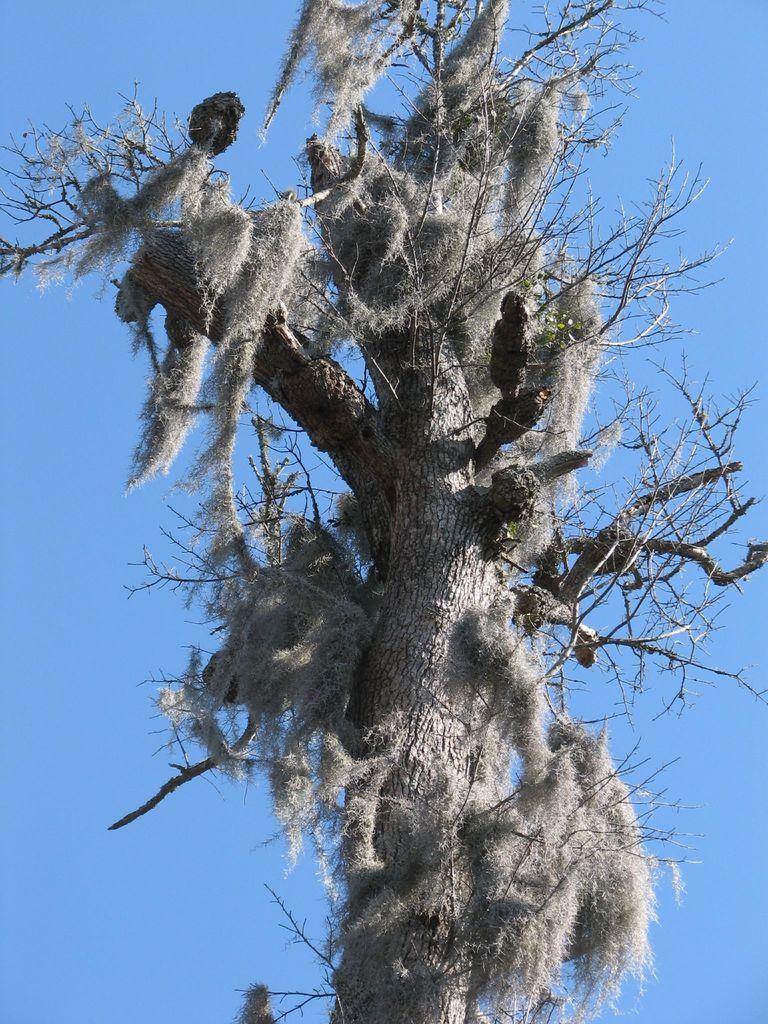Can you describe this image briefly? In the center of the image a tree is there. In the background of the image sky is there. 